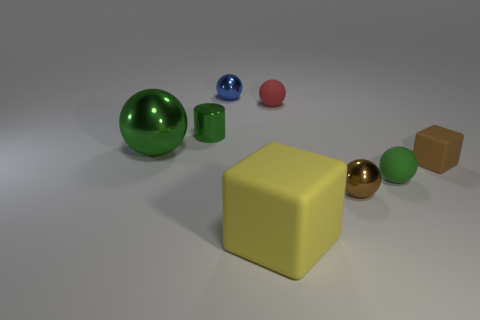Subtract all red spheres. How many spheres are left? 4 Subtract all tiny brown metal spheres. How many spheres are left? 4 Subtract 1 balls. How many balls are left? 4 Subtract all gray spheres. Subtract all green blocks. How many spheres are left? 5 Add 1 small cyan rubber cylinders. How many objects exist? 9 Subtract all balls. How many objects are left? 3 Subtract 0 red cylinders. How many objects are left? 8 Subtract all metal balls. Subtract all brown shiny objects. How many objects are left? 4 Add 7 large metallic balls. How many large metallic balls are left? 8 Add 4 small blue spheres. How many small blue spheres exist? 5 